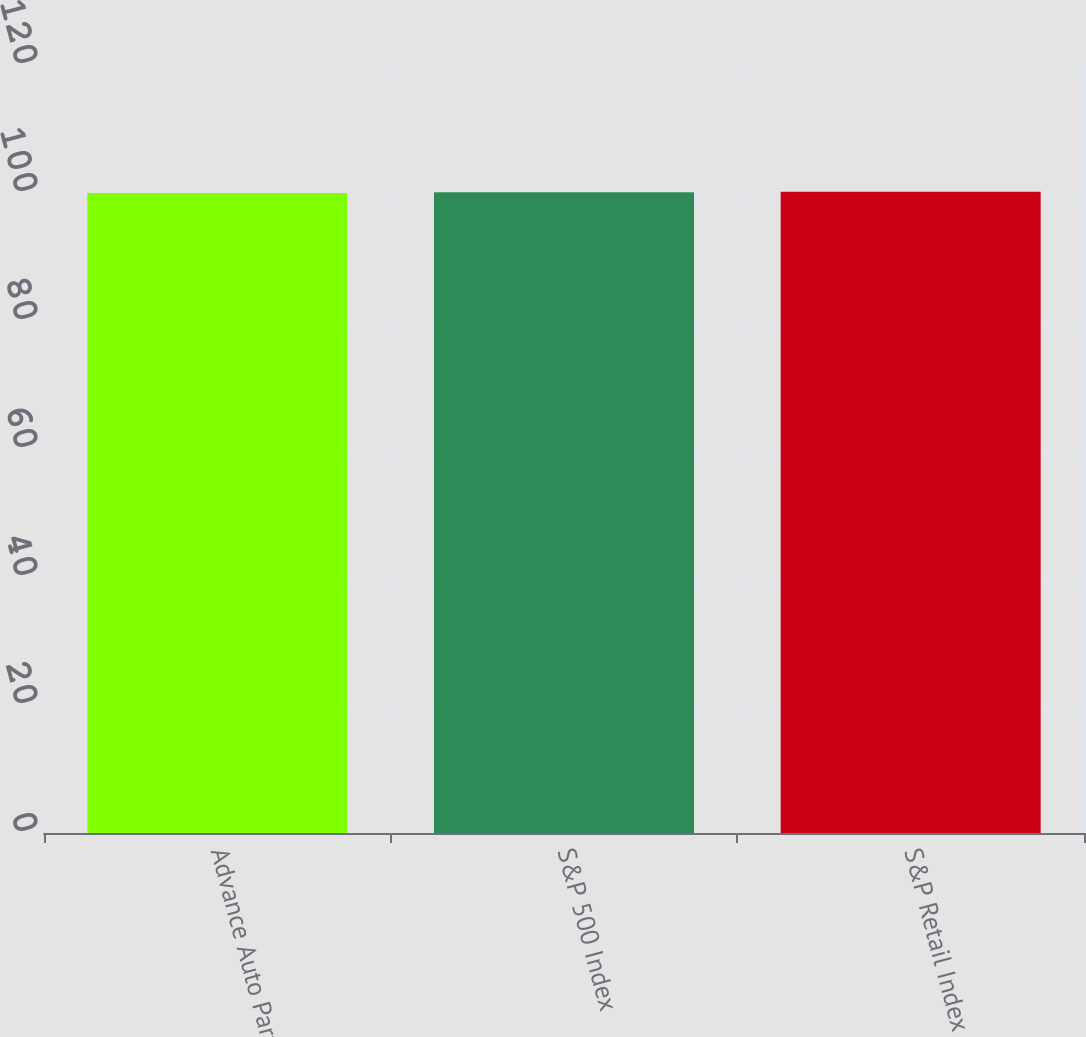Convert chart. <chart><loc_0><loc_0><loc_500><loc_500><bar_chart><fcel>Advance Auto Parts<fcel>S&P 500 Index<fcel>S&P Retail Index<nl><fcel>100<fcel>100.1<fcel>100.2<nl></chart> 